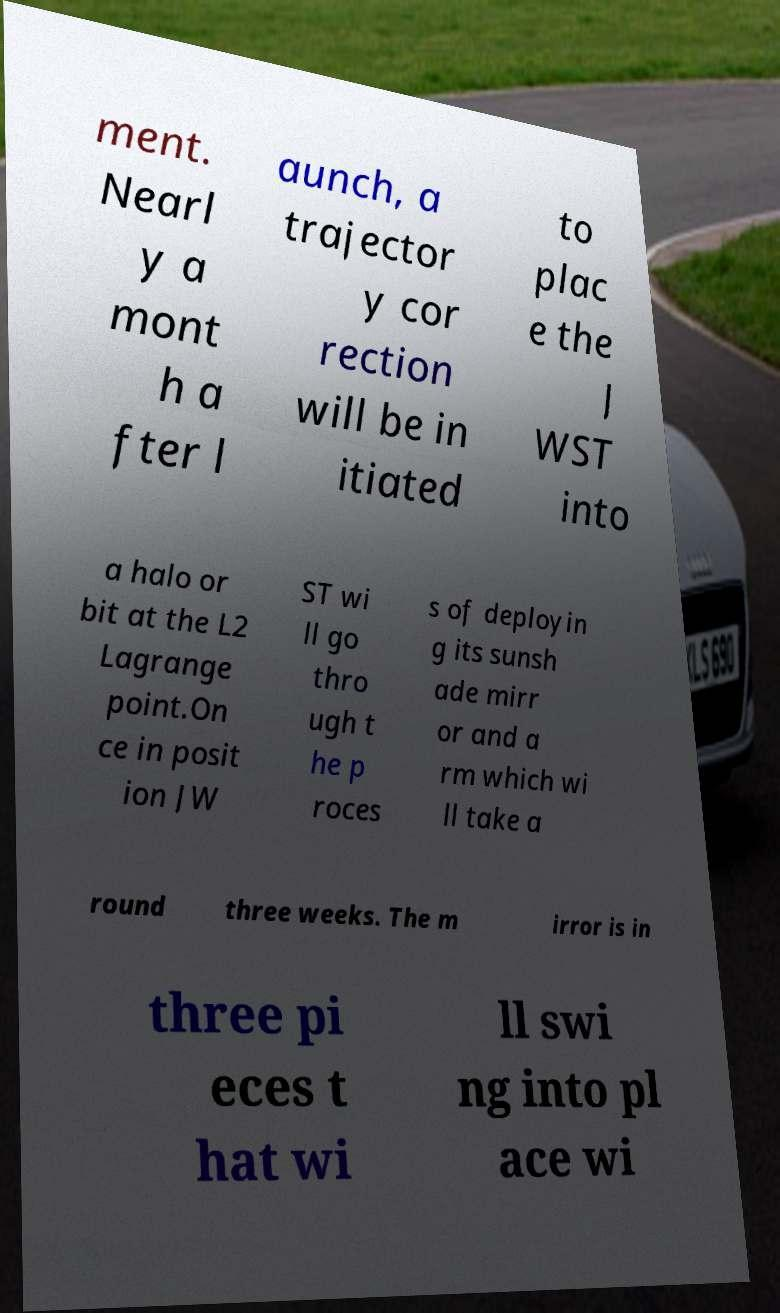There's text embedded in this image that I need extracted. Can you transcribe it verbatim? ment. Nearl y a mont h a fter l aunch, a trajector y cor rection will be in itiated to plac e the J WST into a halo or bit at the L2 Lagrange point.On ce in posit ion JW ST wi ll go thro ugh t he p roces s of deployin g its sunsh ade mirr or and a rm which wi ll take a round three weeks. The m irror is in three pi eces t hat wi ll swi ng into pl ace wi 